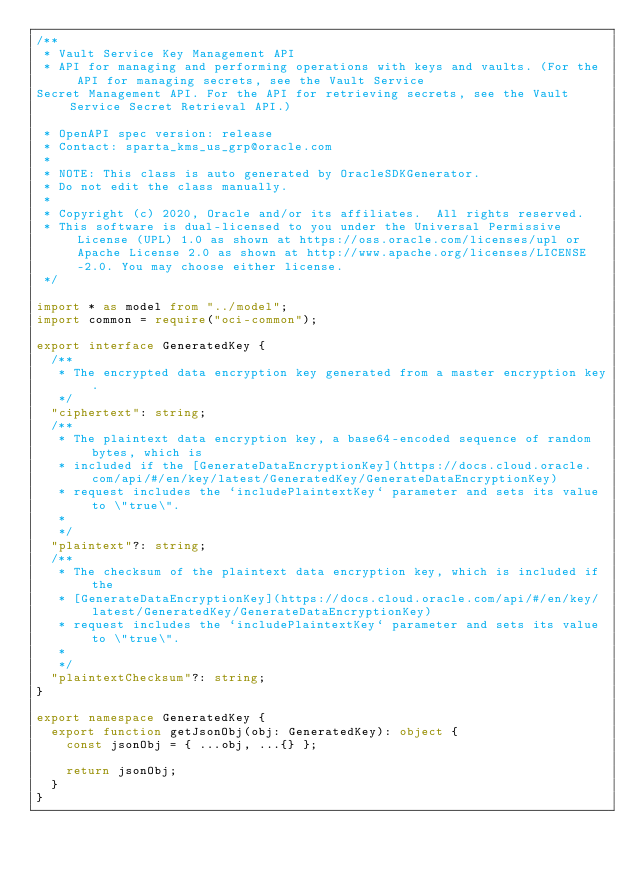Convert code to text. <code><loc_0><loc_0><loc_500><loc_500><_TypeScript_>/**
 * Vault Service Key Management API
 * API for managing and performing operations with keys and vaults. (For the API for managing secrets, see the Vault Service 
Secret Management API. For the API for retrieving secrets, see the Vault Service Secret Retrieval API.)

 * OpenAPI spec version: release
 * Contact: sparta_kms_us_grp@oracle.com
 *
 * NOTE: This class is auto generated by OracleSDKGenerator.
 * Do not edit the class manually.
 *
 * Copyright (c) 2020, Oracle and/or its affiliates.  All rights reserved.
 * This software is dual-licensed to you under the Universal Permissive License (UPL) 1.0 as shown at https://oss.oracle.com/licenses/upl or Apache License 2.0 as shown at http://www.apache.org/licenses/LICENSE-2.0. You may choose either license.
 */

import * as model from "../model";
import common = require("oci-common");

export interface GeneratedKey {
  /**
   * The encrypted data encryption key generated from a master encryption key.
   */
  "ciphertext": string;
  /**
   * The plaintext data encryption key, a base64-encoded sequence of random bytes, which is
   * included if the [GenerateDataEncryptionKey](https://docs.cloud.oracle.com/api/#/en/key/latest/GeneratedKey/GenerateDataEncryptionKey)
   * request includes the `includePlaintextKey` parameter and sets its value to \"true\".
   *
   */
  "plaintext"?: string;
  /**
   * The checksum of the plaintext data encryption key, which is included if the
   * [GenerateDataEncryptionKey](https://docs.cloud.oracle.com/api/#/en/key/latest/GeneratedKey/GenerateDataEncryptionKey)
   * request includes the `includePlaintextKey` parameter and sets its value to \"true\".
   *
   */
  "plaintextChecksum"?: string;
}

export namespace GeneratedKey {
  export function getJsonObj(obj: GeneratedKey): object {
    const jsonObj = { ...obj, ...{} };

    return jsonObj;
  }
}
</code> 